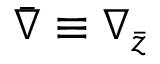Convert formula to latex. <formula><loc_0><loc_0><loc_500><loc_500>\bar { \nabla } \equiv \nabla _ { \bar { z } }</formula> 